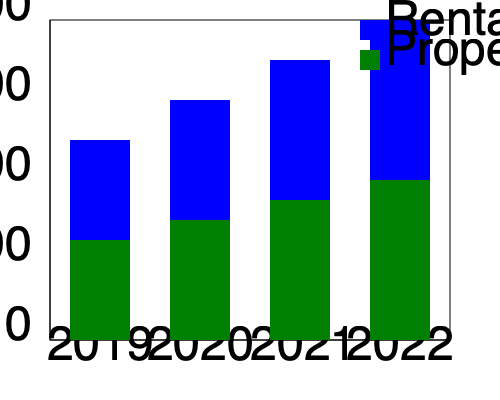Analyze the cash flow trends in real estate investments from 2019 to 2022 using the stacked bar chart. If the total cash flow in 2019 is set as the baseline (100%), calculate the percentage increase in total cash flow for 2022 compared to 2019. To solve this problem, we need to follow these steps:

1. Identify the total cash flow for 2019 and 2022:
   - 2019: Rental Income (200) + Property Value Appreciation (100) = 300
   - 2022: Rental Income (320) + Property Value Appreciation (160) = 480

2. Set 2019 as the baseline (100%):
   300 = 100%

3. Calculate the percentage for 2022:
   Let $x$ be the percentage for 2022.
   $\frac{480}{300} = \frac{x}{100}$

4. Solve for $x$:
   $x = \frac{480 \times 100}{300} = 160$

5. Calculate the percentage increase:
   Percentage increase = 160% - 100% = 60%

Therefore, the percentage increase in total cash flow for 2022 compared to 2019 is 60%.
Answer: 60% 